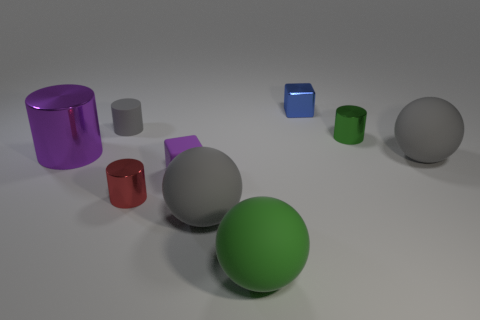There is a gray ball that is right of the metal cube; does it have the same size as the metal thing that is right of the blue block? no 